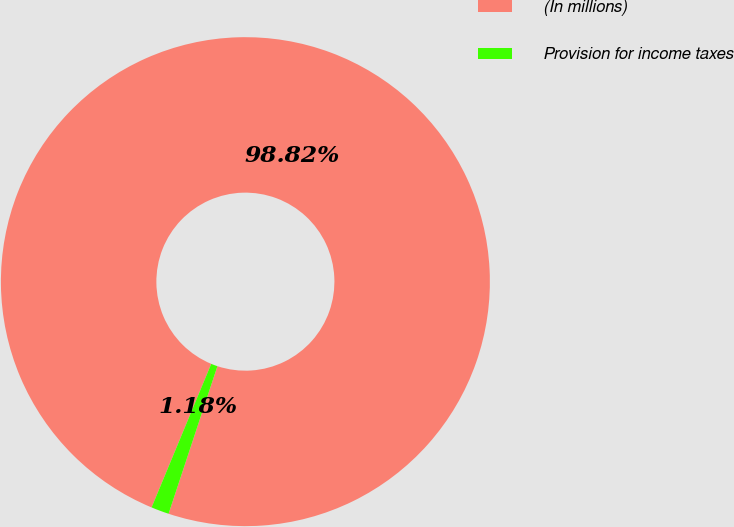<chart> <loc_0><loc_0><loc_500><loc_500><pie_chart><fcel>(In millions)<fcel>Provision for income taxes<nl><fcel>98.82%<fcel>1.18%<nl></chart> 